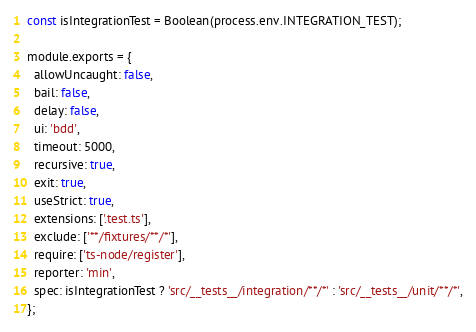<code> <loc_0><loc_0><loc_500><loc_500><_JavaScript_>const isIntegrationTest = Boolean(process.env.INTEGRATION_TEST);

module.exports = {
  allowUncaught: false,
  bail: false,
  delay: false,
  ui: 'bdd',
  timeout: 5000,
  recursive: true,
  exit: true,
  useStrict: true,
  extensions: ['.test.ts'],
  exclude: ['**/fixtures/**/*'],
  require: ['ts-node/register'],
  reporter: 'min',
  spec: isIntegrationTest ? 'src/__tests__/integration/**/*' : 'src/__tests__/unit/**/*',
};
</code> 